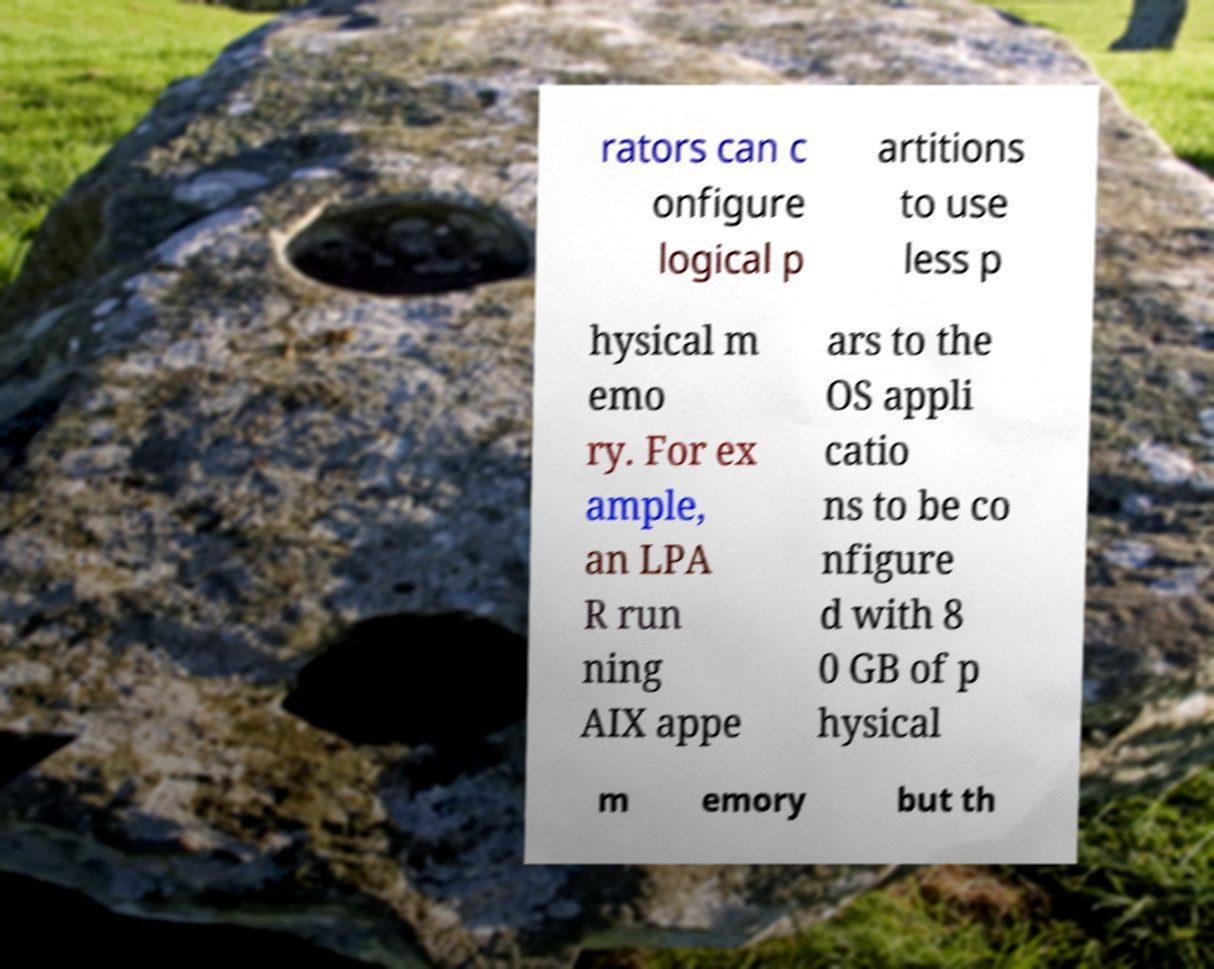What messages or text are displayed in this image? I need them in a readable, typed format. rators can c onfigure logical p artitions to use less p hysical m emo ry. For ex ample, an LPA R run ning AIX appe ars to the OS appli catio ns to be co nfigure d with 8 0 GB of p hysical m emory but th 